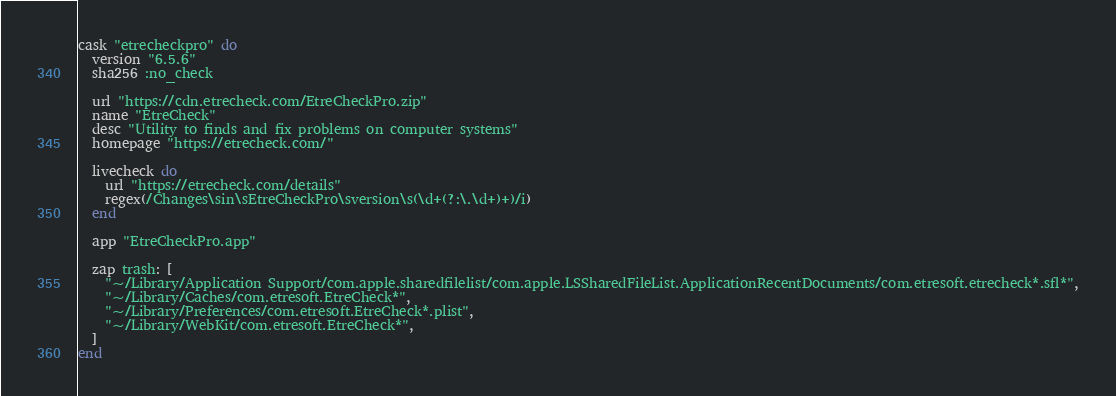<code> <loc_0><loc_0><loc_500><loc_500><_Ruby_>cask "etrecheckpro" do
  version "6.5.6"
  sha256 :no_check

  url "https://cdn.etrecheck.com/EtreCheckPro.zip"
  name "EtreCheck"
  desc "Utility to finds and fix problems on computer systems"
  homepage "https://etrecheck.com/"

  livecheck do
    url "https://etrecheck.com/details"
    regex(/Changes\sin\sEtreCheckPro\sversion\s(\d+(?:\.\d+)+)/i)
  end

  app "EtreCheckPro.app"

  zap trash: [
    "~/Library/Application Support/com.apple.sharedfilelist/com.apple.LSSharedFileList.ApplicationRecentDocuments/com.etresoft.etrecheck*.sfl*",
    "~/Library/Caches/com.etresoft.EtreCheck*",
    "~/Library/Preferences/com.etresoft.EtreCheck*.plist",
    "~/Library/WebKit/com.etresoft.EtreCheck*",
  ]
end
</code> 